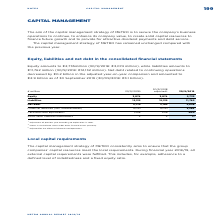According to Metro Ag's financial document, What was the amount of equity in FY2019? Based on the financial document, the answer is €2,735 million. Also, What was the amount of liabilities in FY2019? According to the financial document, €11,762 million. The relevant text states: "€11,762 million (30/9/2018: €12,132 million). Net debt related to continuing operations..." Also, What are the main components in the consolidated financial statements measured in the table? The document contains multiple relevant values: Equity, Liabilities, Net debt. From the document: "Net debt 2,710 3,102 2,858 Liabilities 12,132 12,132 11,762 Equity 3,074 3,074 2,735..." Additionally, In which year was the amount of Equity larger for FY2018 adjusted figures and FY2019 figures? According to the financial document, 2018. The relevant text states: "Equity amounts to €2,735million (30/9/2018: €3,074 million), while liabilities amounts to..." Also, can you calculate: What was the change in equity in FY2019 from FY2018 adjusted? Based on the calculation: 2,735-3,074, the result is -339 (in millions). This is based on the information: "Equity 3,074 3,074 2,735 Equity 3,074 3,074 2,735..." The key data points involved are: 2,735, 3,074. Also, can you calculate: What was the percentage change in equity in FY2019 from FY2018 adjusted? To answer this question, I need to perform calculations using the financial data. The calculation is: (2,735-3,074)/3,074, which equals -11.03 (percentage). This is based on the information: "Equity 3,074 3,074 2,735 Equity 3,074 3,074 2,735..." The key data points involved are: 2,735, 3,074. 